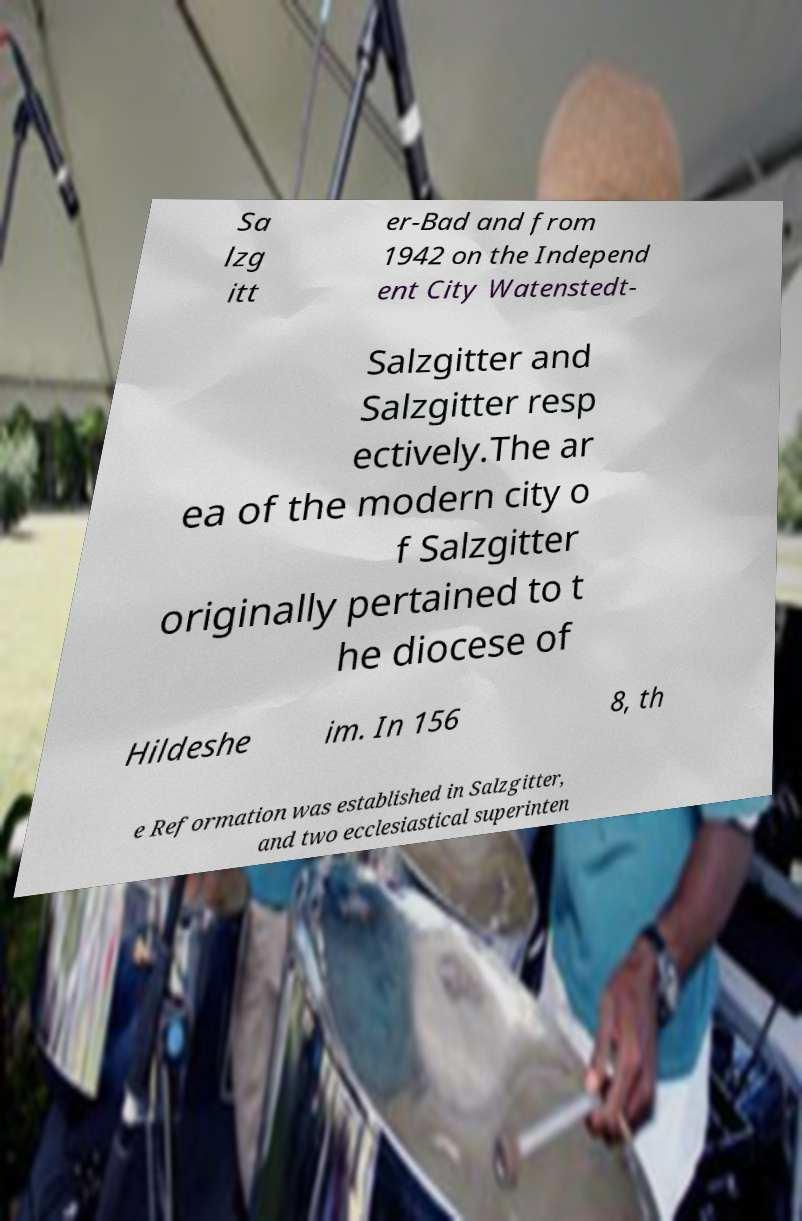Could you extract and type out the text from this image? Sa lzg itt er-Bad and from 1942 on the Independ ent City Watenstedt- Salzgitter and Salzgitter resp ectively.The ar ea of the modern city o f Salzgitter originally pertained to t he diocese of Hildeshe im. In 156 8, th e Reformation was established in Salzgitter, and two ecclesiastical superinten 